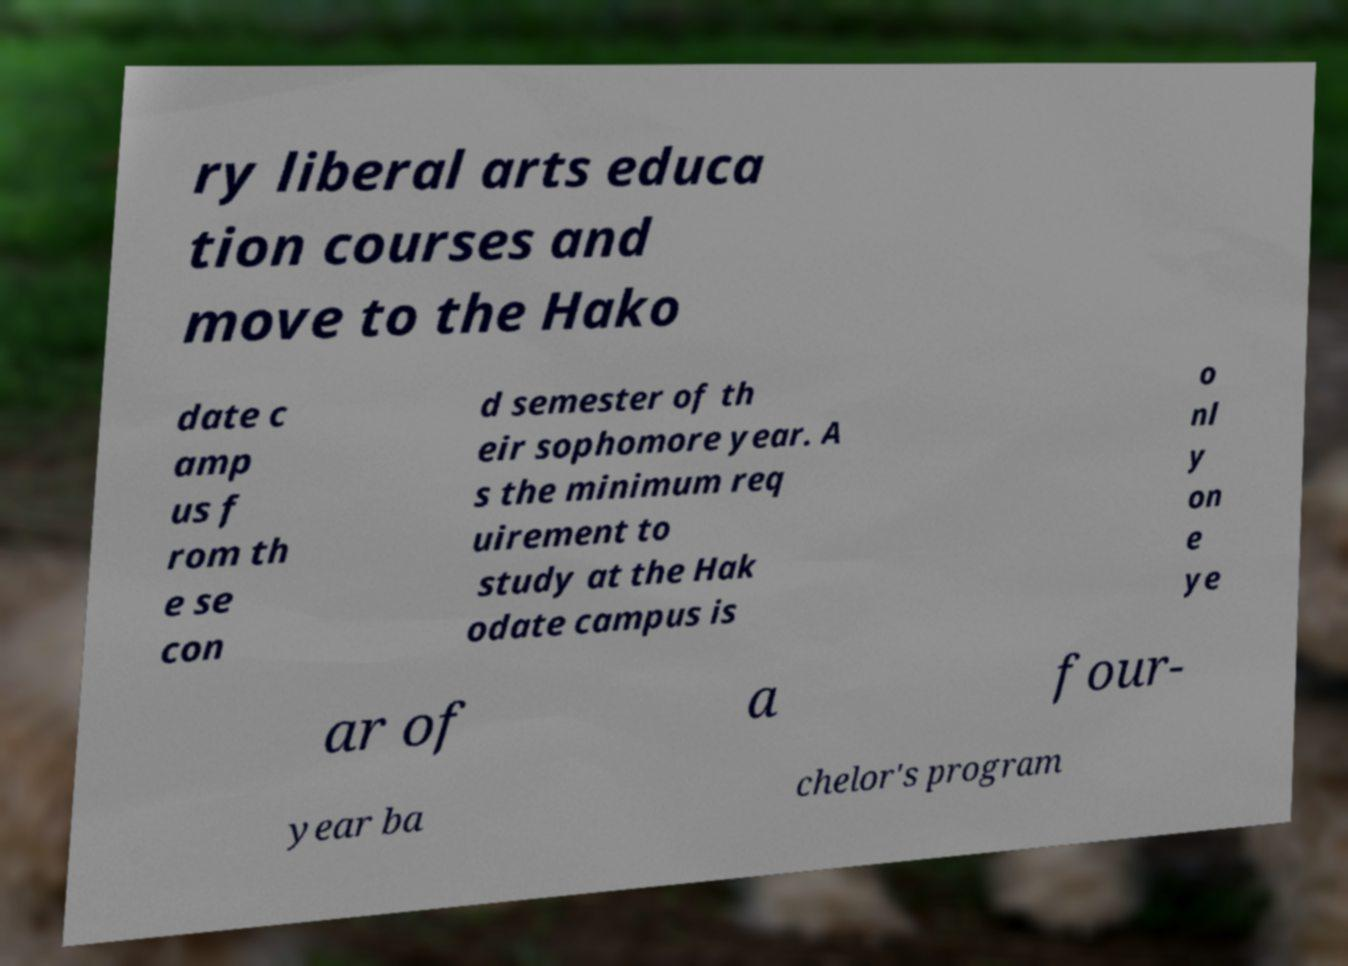For documentation purposes, I need the text within this image transcribed. Could you provide that? ry liberal arts educa tion courses and move to the Hako date c amp us f rom th e se con d semester of th eir sophomore year. A s the minimum req uirement to study at the Hak odate campus is o nl y on e ye ar of a four- year ba chelor's program 